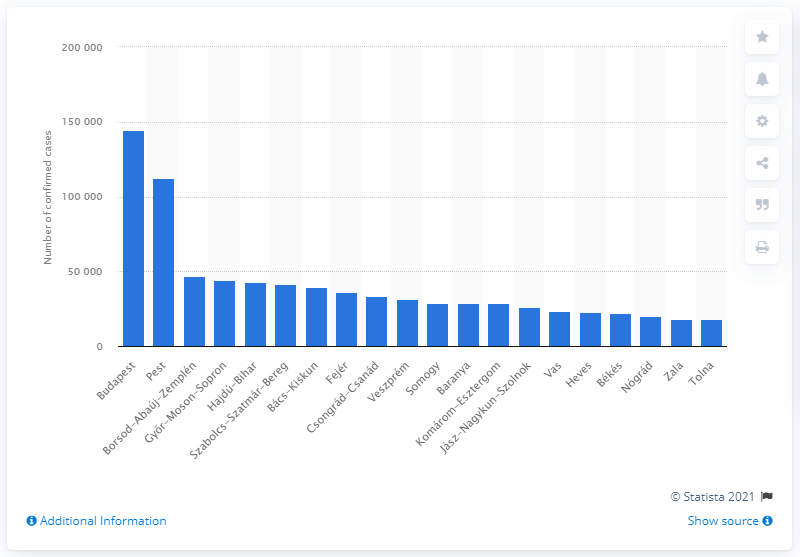Give some essential details in this illustration. According to confirmed cases, Budapest had the highest number of COVID-19 cases. 